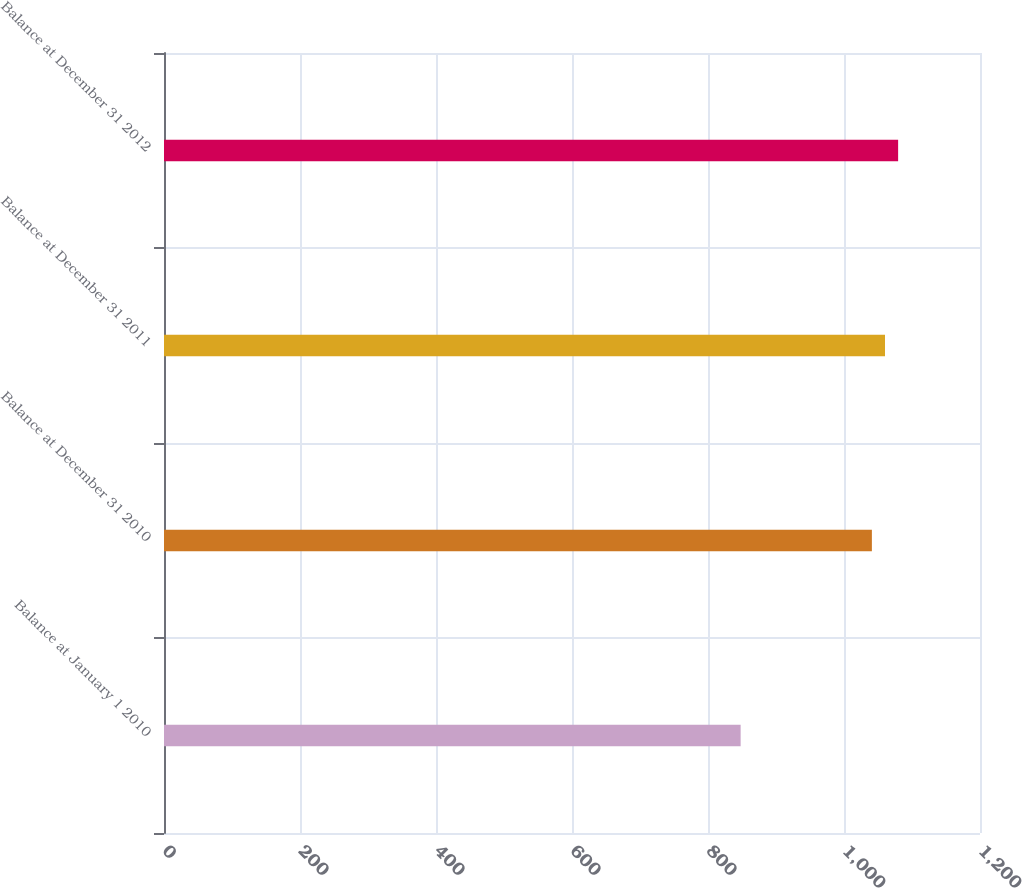<chart> <loc_0><loc_0><loc_500><loc_500><bar_chart><fcel>Balance at January 1 2010<fcel>Balance at December 31 2010<fcel>Balance at December 31 2011<fcel>Balance at December 31 2012<nl><fcel>848<fcel>1041<fcel>1060.3<fcel>1079.6<nl></chart> 